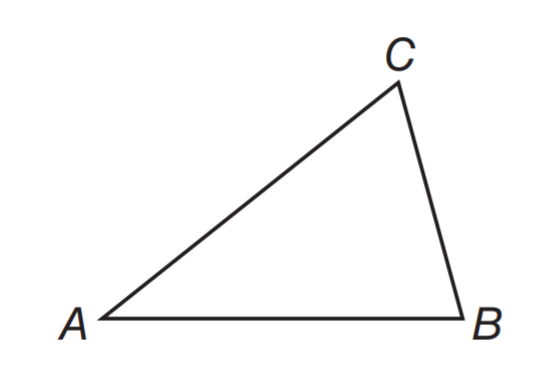Answer the mathemtical geometry problem and directly provide the correct option letter.
Question: m \angle B = 76. The measure of \angle A is half the measure of \angle B. What is m \angle C?
Choices: A: 46 B: 56 C: 66 D: 76 C 